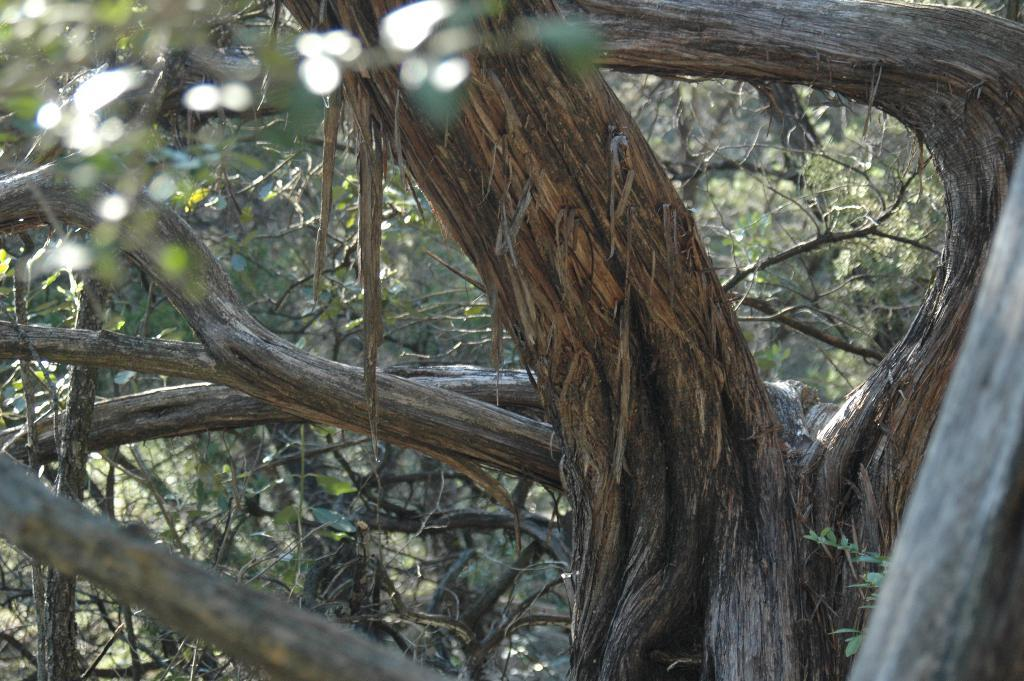What is the primary feature of the image? The primary feature of the image is the presence of many trees. What can be said about the color of the trees? The trees in the image are green in color. What type of pen is being used to write on the bed in the image? There is no pen or bed present in the image; it only features trees. 